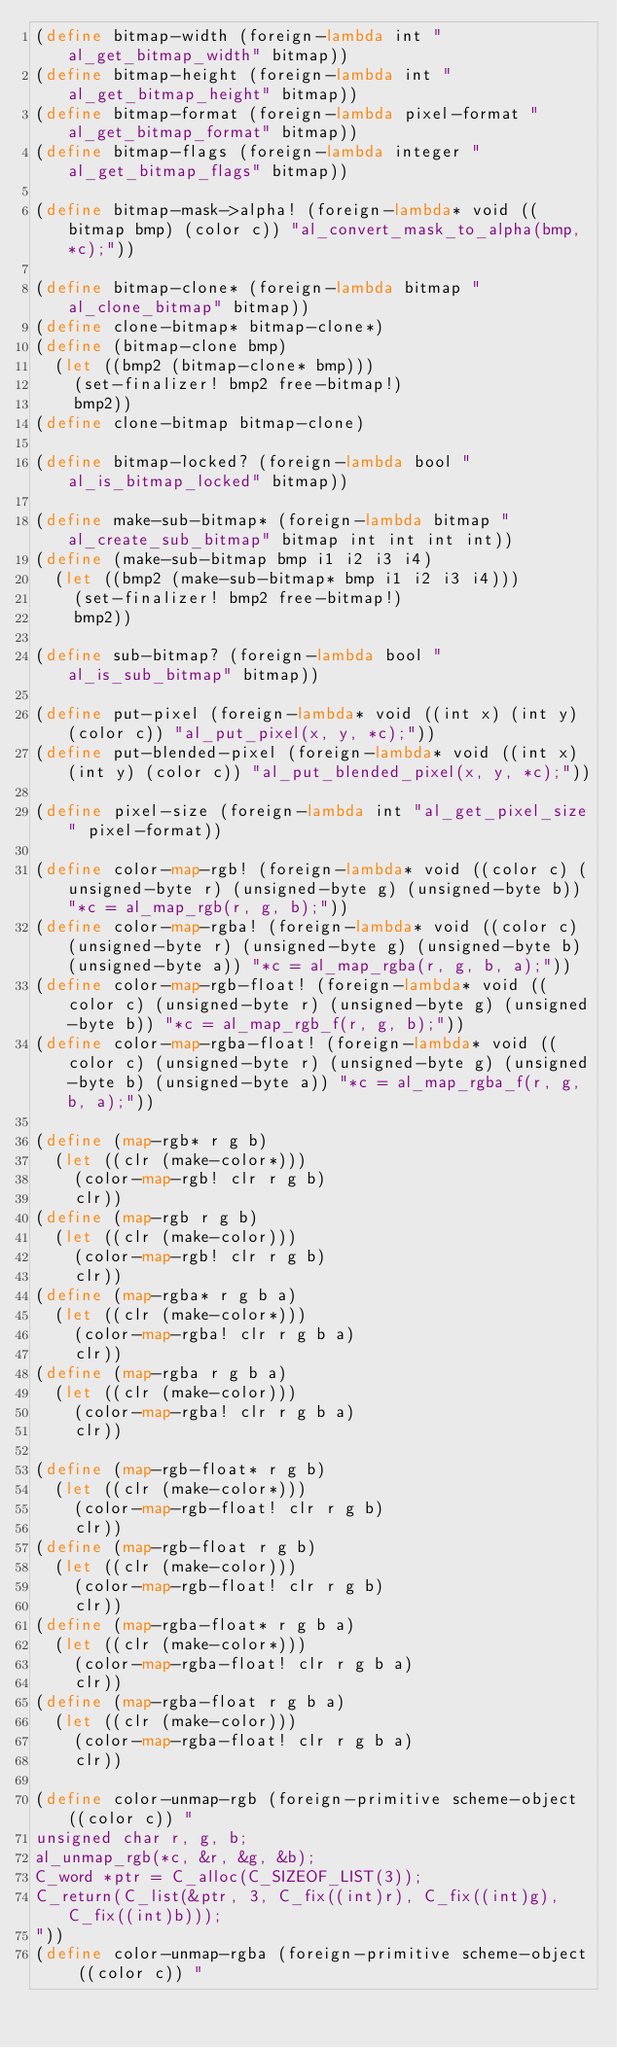<code> <loc_0><loc_0><loc_500><loc_500><_Scheme_>(define bitmap-width (foreign-lambda int "al_get_bitmap_width" bitmap))
(define bitmap-height (foreign-lambda int "al_get_bitmap_height" bitmap))
(define bitmap-format (foreign-lambda pixel-format "al_get_bitmap_format" bitmap))
(define bitmap-flags (foreign-lambda integer "al_get_bitmap_flags" bitmap))

(define bitmap-mask->alpha! (foreign-lambda* void ((bitmap bmp) (color c)) "al_convert_mask_to_alpha(bmp, *c);"))

(define bitmap-clone* (foreign-lambda bitmap "al_clone_bitmap" bitmap))
(define clone-bitmap* bitmap-clone*)
(define (bitmap-clone bmp)
  (let ((bmp2 (bitmap-clone* bmp)))
    (set-finalizer! bmp2 free-bitmap!)
    bmp2))
(define clone-bitmap bitmap-clone)

(define bitmap-locked? (foreign-lambda bool "al_is_bitmap_locked" bitmap))

(define make-sub-bitmap* (foreign-lambda bitmap "al_create_sub_bitmap" bitmap int int int int))
(define (make-sub-bitmap bmp i1 i2 i3 i4)
  (let ((bmp2 (make-sub-bitmap* bmp i1 i2 i3 i4)))
    (set-finalizer! bmp2 free-bitmap!)
    bmp2))

(define sub-bitmap? (foreign-lambda bool "al_is_sub_bitmap" bitmap))

(define put-pixel (foreign-lambda* void ((int x) (int y) (color c)) "al_put_pixel(x, y, *c);"))
(define put-blended-pixel (foreign-lambda* void ((int x) (int y) (color c)) "al_put_blended_pixel(x, y, *c);"))

(define pixel-size (foreign-lambda int "al_get_pixel_size" pixel-format))

(define color-map-rgb! (foreign-lambda* void ((color c) (unsigned-byte r) (unsigned-byte g) (unsigned-byte b)) "*c = al_map_rgb(r, g, b);"))
(define color-map-rgba! (foreign-lambda* void ((color c) (unsigned-byte r) (unsigned-byte g) (unsigned-byte b) (unsigned-byte a)) "*c = al_map_rgba(r, g, b, a);"))
(define color-map-rgb-float! (foreign-lambda* void ((color c) (unsigned-byte r) (unsigned-byte g) (unsigned-byte b)) "*c = al_map_rgb_f(r, g, b);"))
(define color-map-rgba-float! (foreign-lambda* void ((color c) (unsigned-byte r) (unsigned-byte g) (unsigned-byte b) (unsigned-byte a)) "*c = al_map_rgba_f(r, g, b, a);"))

(define (map-rgb* r g b)
  (let ((clr (make-color*)))
    (color-map-rgb! clr r g b)
    clr))
(define (map-rgb r g b)
  (let ((clr (make-color)))
    (color-map-rgb! clr r g b)
    clr))
(define (map-rgba* r g b a)
  (let ((clr (make-color*)))
    (color-map-rgba! clr r g b a)
    clr))
(define (map-rgba r g b a)
  (let ((clr (make-color)))
    (color-map-rgba! clr r g b a)
    clr))

(define (map-rgb-float* r g b)
  (let ((clr (make-color*)))
    (color-map-rgb-float! clr r g b)
    clr))
(define (map-rgb-float r g b)
  (let ((clr (make-color)))
    (color-map-rgb-float! clr r g b)
    clr))
(define (map-rgba-float* r g b a)
  (let ((clr (make-color*)))
    (color-map-rgba-float! clr r g b a)
    clr))
(define (map-rgba-float r g b a)
  (let ((clr (make-color)))
    (color-map-rgba-float! clr r g b a)
    clr))

(define color-unmap-rgb (foreign-primitive scheme-object ((color c)) "
unsigned char r, g, b;
al_unmap_rgb(*c, &r, &g, &b);
C_word *ptr = C_alloc(C_SIZEOF_LIST(3));
C_return(C_list(&ptr, 3, C_fix((int)r), C_fix((int)g), C_fix((int)b)));
"))
(define color-unmap-rgba (foreign-primitive scheme-object ((color c)) "</code> 